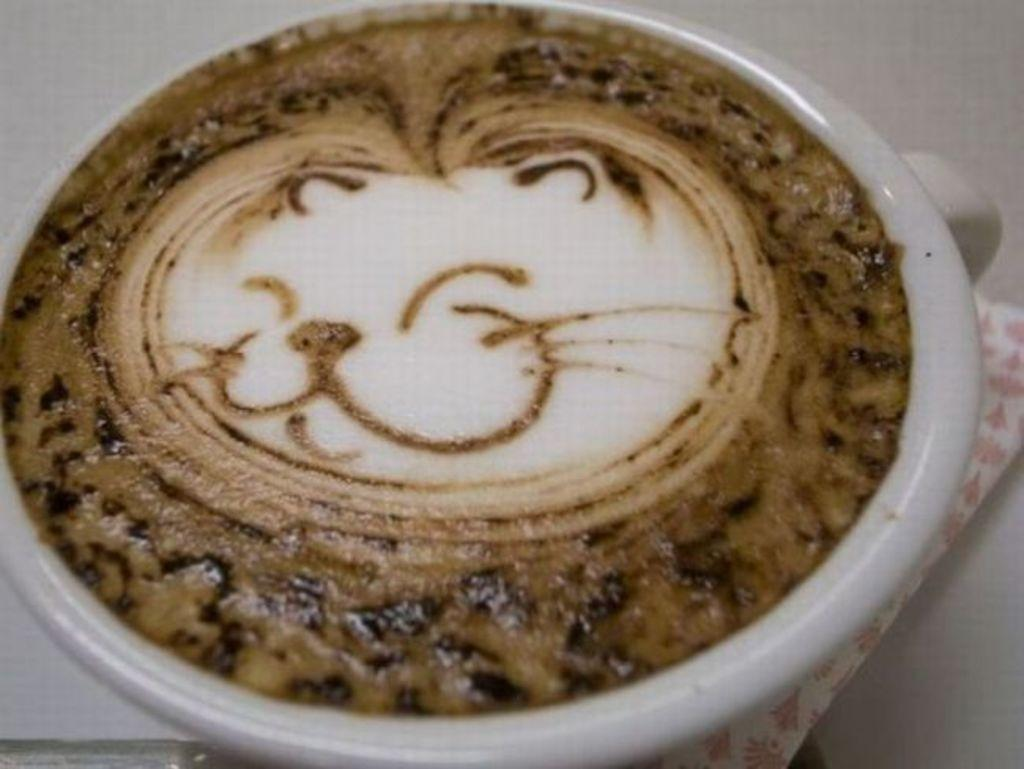What type of cup is in the image? There is a white cup in the image. What is inside the cup? There is coffee inside the cup. Can you describe the art on top of the coffee? Yes, there is art on the top of the coffee. What type of connection can be seen between the cup and the beef in the image? There is no beef present in the image, so there is no connection between the cup and beef. 